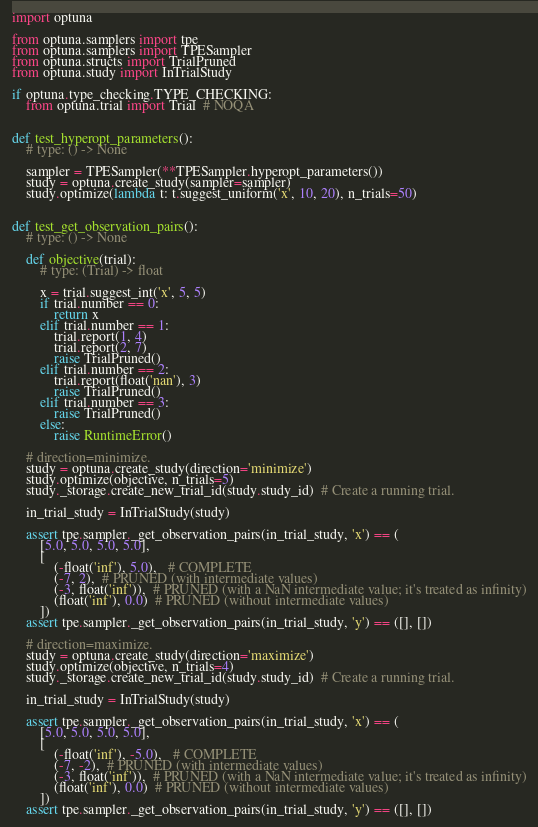Convert code to text. <code><loc_0><loc_0><loc_500><loc_500><_Python_>import optuna

from optuna.samplers import tpe
from optuna.samplers import TPESampler
from optuna.structs import TrialPruned
from optuna.study import InTrialStudy

if optuna.type_checking.TYPE_CHECKING:
    from optuna.trial import Trial  # NOQA


def test_hyperopt_parameters():
    # type: () -> None

    sampler = TPESampler(**TPESampler.hyperopt_parameters())
    study = optuna.create_study(sampler=sampler)
    study.optimize(lambda t: t.suggest_uniform('x', 10, 20), n_trials=50)


def test_get_observation_pairs():
    # type: () -> None

    def objective(trial):
        # type: (Trial) -> float

        x = trial.suggest_int('x', 5, 5)
        if trial.number == 0:
            return x
        elif trial.number == 1:
            trial.report(1, 4)
            trial.report(2, 7)
            raise TrialPruned()
        elif trial.number == 2:
            trial.report(float('nan'), 3)
            raise TrialPruned()
        elif trial.number == 3:
            raise TrialPruned()
        else:
            raise RuntimeError()

    # direction=minimize.
    study = optuna.create_study(direction='minimize')
    study.optimize(objective, n_trials=5)
    study._storage.create_new_trial_id(study.study_id)  # Create a running trial.

    in_trial_study = InTrialStudy(study)

    assert tpe.sampler._get_observation_pairs(in_trial_study, 'x') == (
        [5.0, 5.0, 5.0, 5.0],
        [
            (-float('inf'), 5.0),   # COMPLETE
            (-7, 2),  # PRUNED (with intermediate values)
            (-3, float('inf')),  # PRUNED (with a NaN intermediate value; it's treated as infinity)
            (float('inf'), 0.0)  # PRUNED (without intermediate values)
        ])
    assert tpe.sampler._get_observation_pairs(in_trial_study, 'y') == ([], [])

    # direction=maximize.
    study = optuna.create_study(direction='maximize')
    study.optimize(objective, n_trials=4)
    study._storage.create_new_trial_id(study.study_id)  # Create a running trial.

    in_trial_study = InTrialStudy(study)

    assert tpe.sampler._get_observation_pairs(in_trial_study, 'x') == (
        [5.0, 5.0, 5.0, 5.0],
        [
            (-float('inf'), -5.0),   # COMPLETE
            (-7, -2),  # PRUNED (with intermediate values)
            (-3, float('inf')),  # PRUNED (with a NaN intermediate value; it's treated as infinity)
            (float('inf'), 0.0)  # PRUNED (without intermediate values)
        ])
    assert tpe.sampler._get_observation_pairs(in_trial_study, 'y') == ([], [])
</code> 